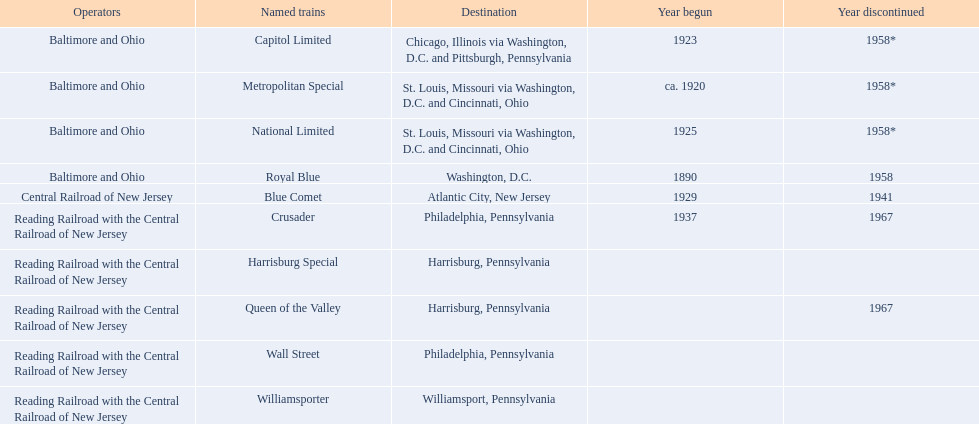What is the total of named trains? 10. 